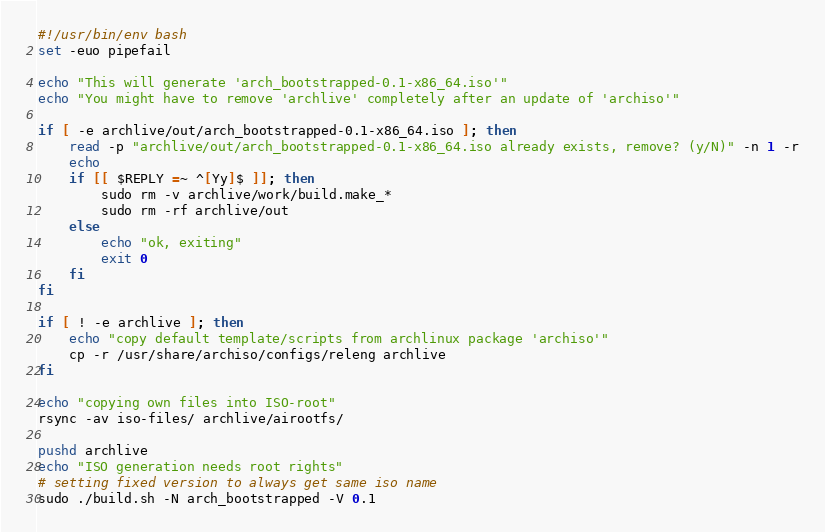<code> <loc_0><loc_0><loc_500><loc_500><_Bash_>#!/usr/bin/env bash
set -euo pipefail

echo "This will generate 'arch_bootstrapped-0.1-x86_64.iso'"
echo "You might have to remove 'archlive' completely after an update of 'archiso'"

if [ -e archlive/out/arch_bootstrapped-0.1-x86_64.iso ]; then
    read -p "archlive/out/arch_bootstrapped-0.1-x86_64.iso already exists, remove? (y/N)" -n 1 -r
    echo
    if [[ $REPLY =~ ^[Yy]$ ]]; then
        sudo rm -v archlive/work/build.make_*
        sudo rm -rf archlive/out
    else
        echo "ok, exiting"
        exit 0
    fi
fi

if [ ! -e archlive ]; then
    echo "copy default template/scripts from archlinux package 'archiso'"
    cp -r /usr/share/archiso/configs/releng archlive
fi

echo "copying own files into ISO-root"
rsync -av iso-files/ archlive/airootfs/

pushd archlive
echo "ISO generation needs root rights"
# setting fixed version to always get same iso name
sudo ./build.sh -N arch_bootstrapped -V 0.1
</code> 